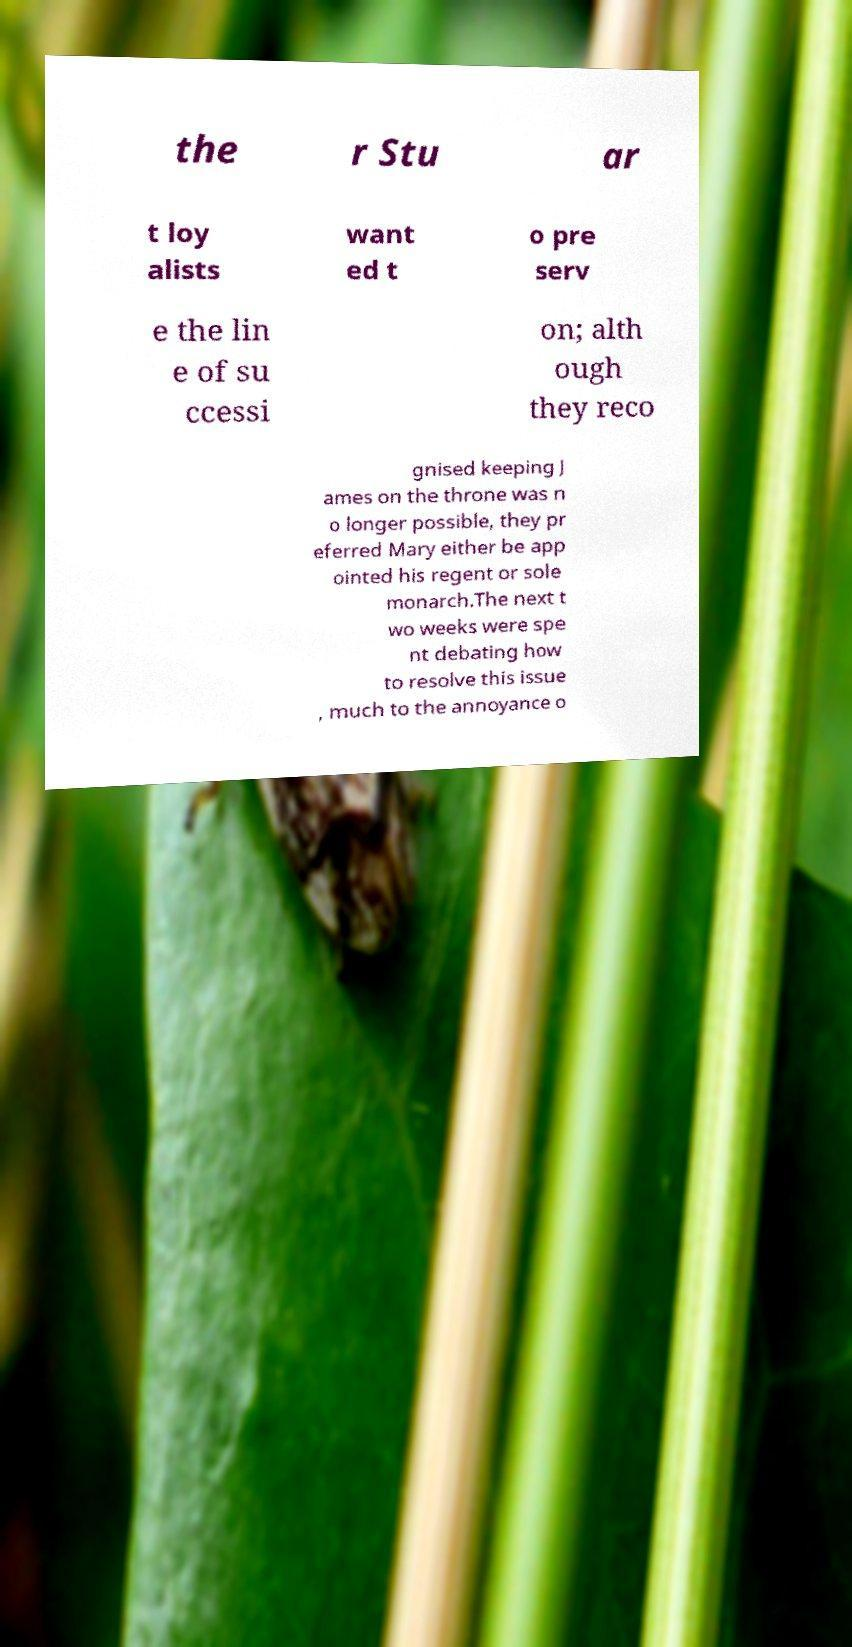Please read and relay the text visible in this image. What does it say? the r Stu ar t loy alists want ed t o pre serv e the lin e of su ccessi on; alth ough they reco gnised keeping J ames on the throne was n o longer possible, they pr eferred Mary either be app ointed his regent or sole monarch.The next t wo weeks were spe nt debating how to resolve this issue , much to the annoyance o 